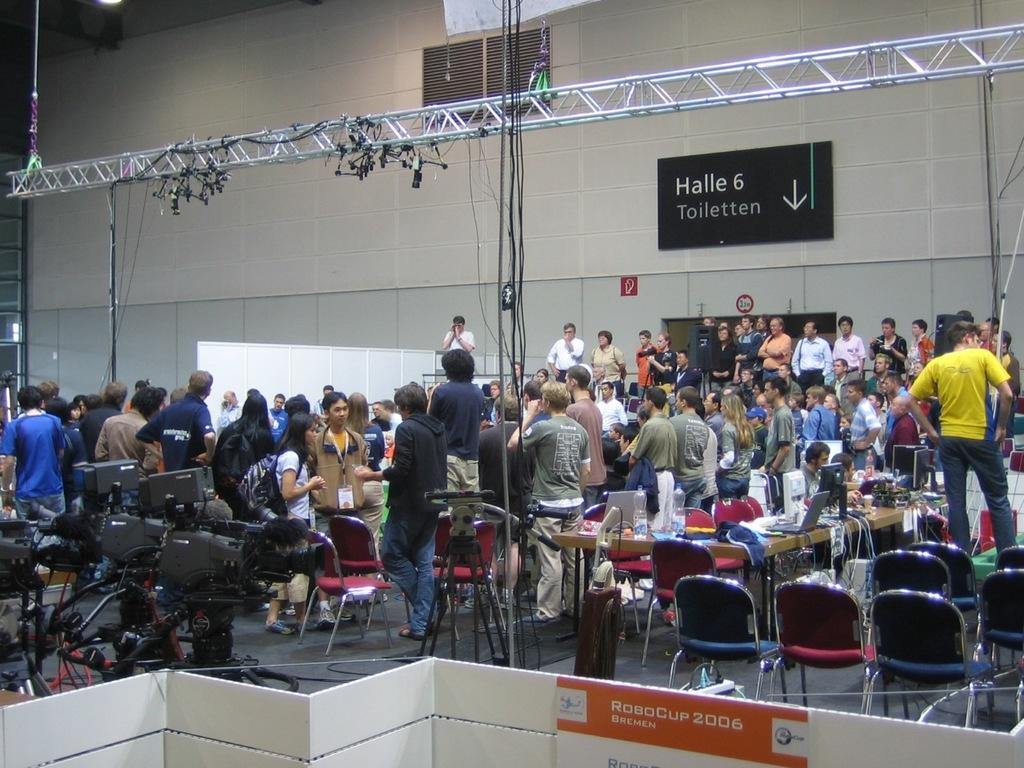What is the position of the group of people in the image? The group of people is standing on the floor in the image. What type of furniture can be seen in the image? There are chairs in the image. What else is visible in the image besides the people and chairs? Wires and cameras are present in the image. What is attached to the wall in the image? There are objects attached to the wall in the image. What other objects can be seen on the floor besides the people and chairs? There are other objects on the floor in the image. How does the system of pleasure work in the image? There is no system of pleasure present in the image; it is a group of people standing on the floor with chairs, wires, cameras, and objects attached to the wall. 